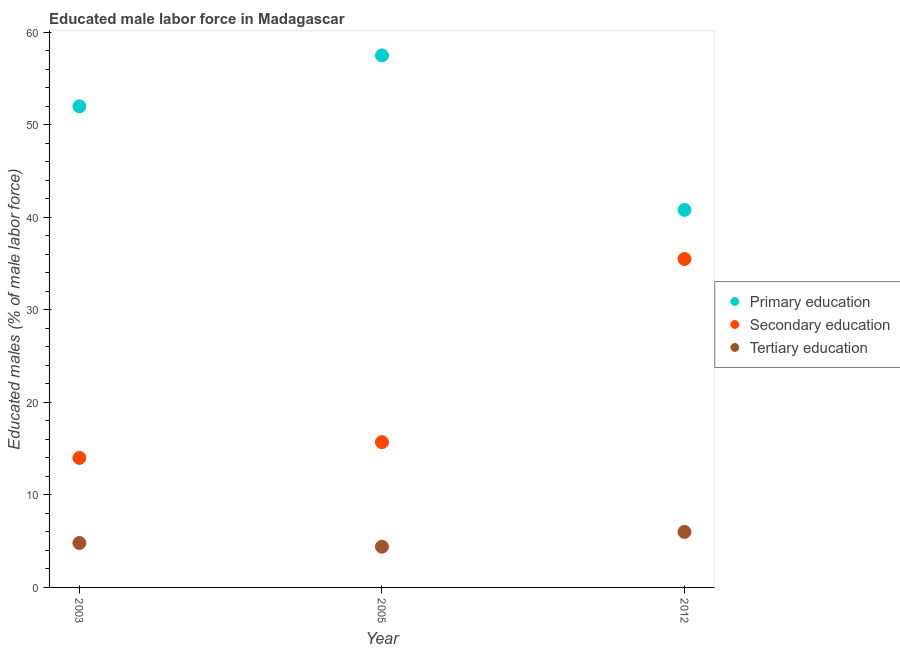How many different coloured dotlines are there?
Provide a succinct answer. 3. Is the number of dotlines equal to the number of legend labels?
Your response must be concise. Yes. What is the percentage of male labor force who received secondary education in 2012?
Make the answer very short. 35.5. Across all years, what is the maximum percentage of male labor force who received primary education?
Ensure brevity in your answer.  57.5. Across all years, what is the minimum percentage of male labor force who received primary education?
Your answer should be compact. 40.8. In which year was the percentage of male labor force who received secondary education maximum?
Keep it short and to the point. 2012. What is the total percentage of male labor force who received primary education in the graph?
Provide a short and direct response. 150.3. What is the difference between the percentage of male labor force who received secondary education in 2005 and that in 2012?
Ensure brevity in your answer.  -19.8. What is the difference between the percentage of male labor force who received secondary education in 2003 and the percentage of male labor force who received primary education in 2005?
Offer a very short reply. -43.5. What is the average percentage of male labor force who received tertiary education per year?
Your response must be concise. 5.07. In the year 2003, what is the difference between the percentage of male labor force who received tertiary education and percentage of male labor force who received secondary education?
Offer a very short reply. -9.2. What is the ratio of the percentage of male labor force who received secondary education in 2003 to that in 2012?
Offer a very short reply. 0.39. Is the percentage of male labor force who received secondary education in 2003 less than that in 2012?
Ensure brevity in your answer.  Yes. What is the difference between the highest and the lowest percentage of male labor force who received primary education?
Provide a short and direct response. 16.7. Is the sum of the percentage of male labor force who received primary education in 2005 and 2012 greater than the maximum percentage of male labor force who received tertiary education across all years?
Your response must be concise. Yes. Is the percentage of male labor force who received tertiary education strictly less than the percentage of male labor force who received secondary education over the years?
Offer a very short reply. Yes. Are the values on the major ticks of Y-axis written in scientific E-notation?
Offer a terse response. No. Does the graph contain any zero values?
Keep it short and to the point. No. How many legend labels are there?
Give a very brief answer. 3. How are the legend labels stacked?
Ensure brevity in your answer.  Vertical. What is the title of the graph?
Ensure brevity in your answer.  Educated male labor force in Madagascar. What is the label or title of the Y-axis?
Offer a very short reply. Educated males (% of male labor force). What is the Educated males (% of male labor force) in Primary education in 2003?
Make the answer very short. 52. What is the Educated males (% of male labor force) of Tertiary education in 2003?
Offer a terse response. 4.8. What is the Educated males (% of male labor force) of Primary education in 2005?
Your response must be concise. 57.5. What is the Educated males (% of male labor force) in Secondary education in 2005?
Your answer should be very brief. 15.7. What is the Educated males (% of male labor force) of Tertiary education in 2005?
Offer a very short reply. 4.4. What is the Educated males (% of male labor force) in Primary education in 2012?
Your answer should be very brief. 40.8. What is the Educated males (% of male labor force) of Secondary education in 2012?
Your answer should be very brief. 35.5. What is the Educated males (% of male labor force) in Tertiary education in 2012?
Provide a succinct answer. 6. Across all years, what is the maximum Educated males (% of male labor force) of Primary education?
Make the answer very short. 57.5. Across all years, what is the maximum Educated males (% of male labor force) in Secondary education?
Offer a terse response. 35.5. Across all years, what is the maximum Educated males (% of male labor force) in Tertiary education?
Your answer should be very brief. 6. Across all years, what is the minimum Educated males (% of male labor force) in Primary education?
Provide a succinct answer. 40.8. Across all years, what is the minimum Educated males (% of male labor force) in Secondary education?
Your answer should be very brief. 14. Across all years, what is the minimum Educated males (% of male labor force) in Tertiary education?
Keep it short and to the point. 4.4. What is the total Educated males (% of male labor force) of Primary education in the graph?
Give a very brief answer. 150.3. What is the total Educated males (% of male labor force) of Secondary education in the graph?
Make the answer very short. 65.2. What is the total Educated males (% of male labor force) of Tertiary education in the graph?
Your response must be concise. 15.2. What is the difference between the Educated males (% of male labor force) in Primary education in 2003 and that in 2005?
Offer a very short reply. -5.5. What is the difference between the Educated males (% of male labor force) in Secondary education in 2003 and that in 2005?
Offer a very short reply. -1.7. What is the difference between the Educated males (% of male labor force) in Tertiary education in 2003 and that in 2005?
Give a very brief answer. 0.4. What is the difference between the Educated males (% of male labor force) in Secondary education in 2003 and that in 2012?
Offer a very short reply. -21.5. What is the difference between the Educated males (% of male labor force) in Primary education in 2005 and that in 2012?
Your answer should be compact. 16.7. What is the difference between the Educated males (% of male labor force) in Secondary education in 2005 and that in 2012?
Give a very brief answer. -19.8. What is the difference between the Educated males (% of male labor force) of Primary education in 2003 and the Educated males (% of male labor force) of Secondary education in 2005?
Keep it short and to the point. 36.3. What is the difference between the Educated males (% of male labor force) of Primary education in 2003 and the Educated males (% of male labor force) of Tertiary education in 2005?
Your answer should be very brief. 47.6. What is the difference between the Educated males (% of male labor force) of Primary education in 2003 and the Educated males (% of male labor force) of Secondary education in 2012?
Offer a very short reply. 16.5. What is the difference between the Educated males (% of male labor force) in Primary education in 2003 and the Educated males (% of male labor force) in Tertiary education in 2012?
Provide a short and direct response. 46. What is the difference between the Educated males (% of male labor force) in Primary education in 2005 and the Educated males (% of male labor force) in Secondary education in 2012?
Provide a succinct answer. 22. What is the difference between the Educated males (% of male labor force) in Primary education in 2005 and the Educated males (% of male labor force) in Tertiary education in 2012?
Your answer should be very brief. 51.5. What is the difference between the Educated males (% of male labor force) in Secondary education in 2005 and the Educated males (% of male labor force) in Tertiary education in 2012?
Provide a short and direct response. 9.7. What is the average Educated males (% of male labor force) in Primary education per year?
Your response must be concise. 50.1. What is the average Educated males (% of male labor force) of Secondary education per year?
Provide a short and direct response. 21.73. What is the average Educated males (% of male labor force) in Tertiary education per year?
Your response must be concise. 5.07. In the year 2003, what is the difference between the Educated males (% of male labor force) of Primary education and Educated males (% of male labor force) of Secondary education?
Make the answer very short. 38. In the year 2003, what is the difference between the Educated males (% of male labor force) in Primary education and Educated males (% of male labor force) in Tertiary education?
Ensure brevity in your answer.  47.2. In the year 2003, what is the difference between the Educated males (% of male labor force) in Secondary education and Educated males (% of male labor force) in Tertiary education?
Offer a very short reply. 9.2. In the year 2005, what is the difference between the Educated males (% of male labor force) of Primary education and Educated males (% of male labor force) of Secondary education?
Make the answer very short. 41.8. In the year 2005, what is the difference between the Educated males (% of male labor force) of Primary education and Educated males (% of male labor force) of Tertiary education?
Offer a very short reply. 53.1. In the year 2012, what is the difference between the Educated males (% of male labor force) in Primary education and Educated males (% of male labor force) in Secondary education?
Offer a terse response. 5.3. In the year 2012, what is the difference between the Educated males (% of male labor force) of Primary education and Educated males (% of male labor force) of Tertiary education?
Give a very brief answer. 34.8. In the year 2012, what is the difference between the Educated males (% of male labor force) in Secondary education and Educated males (% of male labor force) in Tertiary education?
Provide a short and direct response. 29.5. What is the ratio of the Educated males (% of male labor force) in Primary education in 2003 to that in 2005?
Make the answer very short. 0.9. What is the ratio of the Educated males (% of male labor force) in Secondary education in 2003 to that in 2005?
Keep it short and to the point. 0.89. What is the ratio of the Educated males (% of male labor force) in Primary education in 2003 to that in 2012?
Your response must be concise. 1.27. What is the ratio of the Educated males (% of male labor force) of Secondary education in 2003 to that in 2012?
Make the answer very short. 0.39. What is the ratio of the Educated males (% of male labor force) of Tertiary education in 2003 to that in 2012?
Offer a very short reply. 0.8. What is the ratio of the Educated males (% of male labor force) of Primary education in 2005 to that in 2012?
Give a very brief answer. 1.41. What is the ratio of the Educated males (% of male labor force) of Secondary education in 2005 to that in 2012?
Offer a very short reply. 0.44. What is the ratio of the Educated males (% of male labor force) of Tertiary education in 2005 to that in 2012?
Provide a short and direct response. 0.73. What is the difference between the highest and the second highest Educated males (% of male labor force) of Primary education?
Provide a short and direct response. 5.5. What is the difference between the highest and the second highest Educated males (% of male labor force) of Secondary education?
Ensure brevity in your answer.  19.8. What is the difference between the highest and the second highest Educated males (% of male labor force) of Tertiary education?
Offer a terse response. 1.2. What is the difference between the highest and the lowest Educated males (% of male labor force) in Tertiary education?
Make the answer very short. 1.6. 